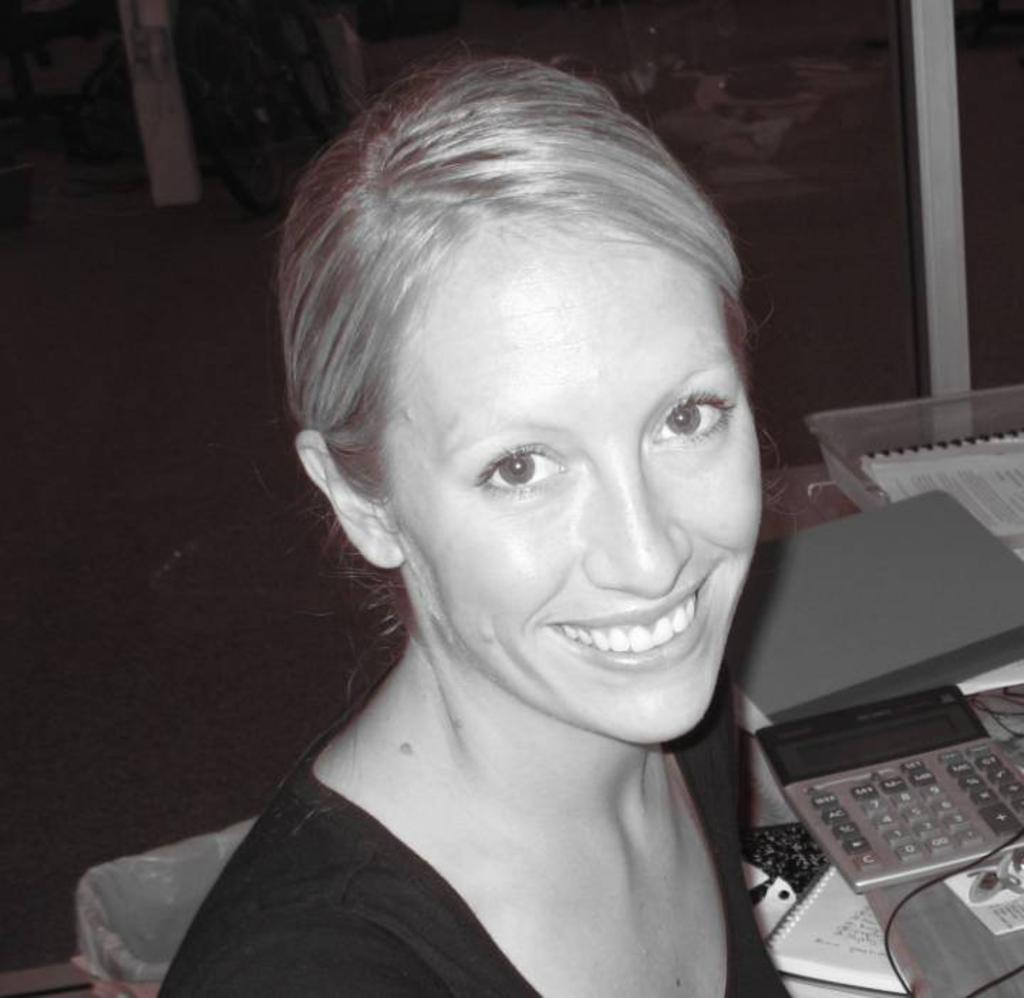What is the main subject in the foreground of the image? There is a woman in the foreground of the image. What can be seen in the background of the image? There is a calculator, books, and other objects in the background of the image. What type of apparel is the train wearing in the image? There is no train present in the image, and therefore no apparel can be associated with it. 